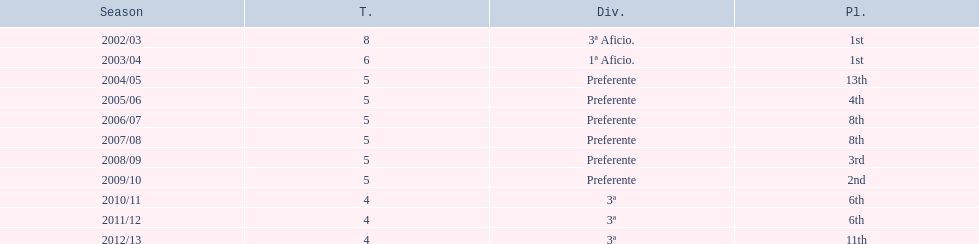In which year did the squad attain the identical position as 2010/11? 2011/12. 